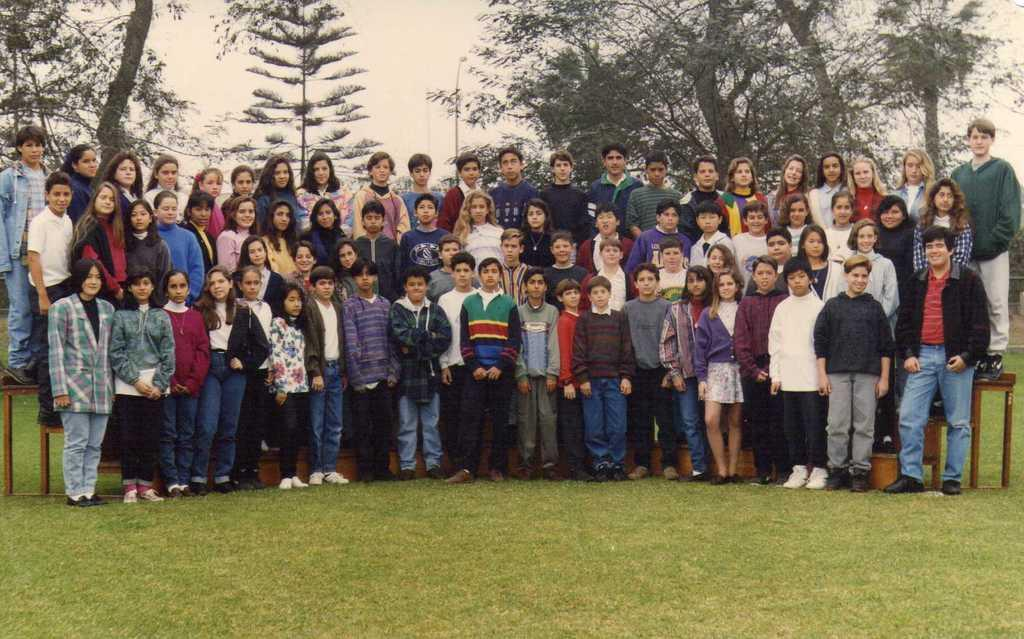What is the main subject of the image? The main subject of the image is a group of children. Where are the children standing in the image? The children are standing on three steps. What is the surface beneath the steps? The steps are on a grass surface. What can be seen in the background of the image? There are trees visible in the background of the image. What type of test is being conducted on the children in the image? There is no test being conducted on the children in the image; they are simply standing on the steps. Can you see any wrens in the image? There are no wrens present in the image. 